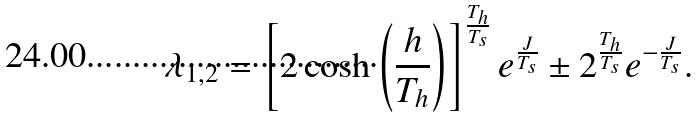<formula> <loc_0><loc_0><loc_500><loc_500>\lambda _ { 1 , 2 } = \left [ 2 \cosh \left ( \frac { h } { T _ { h } } \right ) \right ] ^ { \frac { T _ { h } } { T _ { s } } } e ^ { \frac { J } { T _ { s } } } \pm 2 ^ { \frac { T _ { h } } { T _ { s } } } e ^ { - \frac { J } { T _ { s } } } .</formula> 